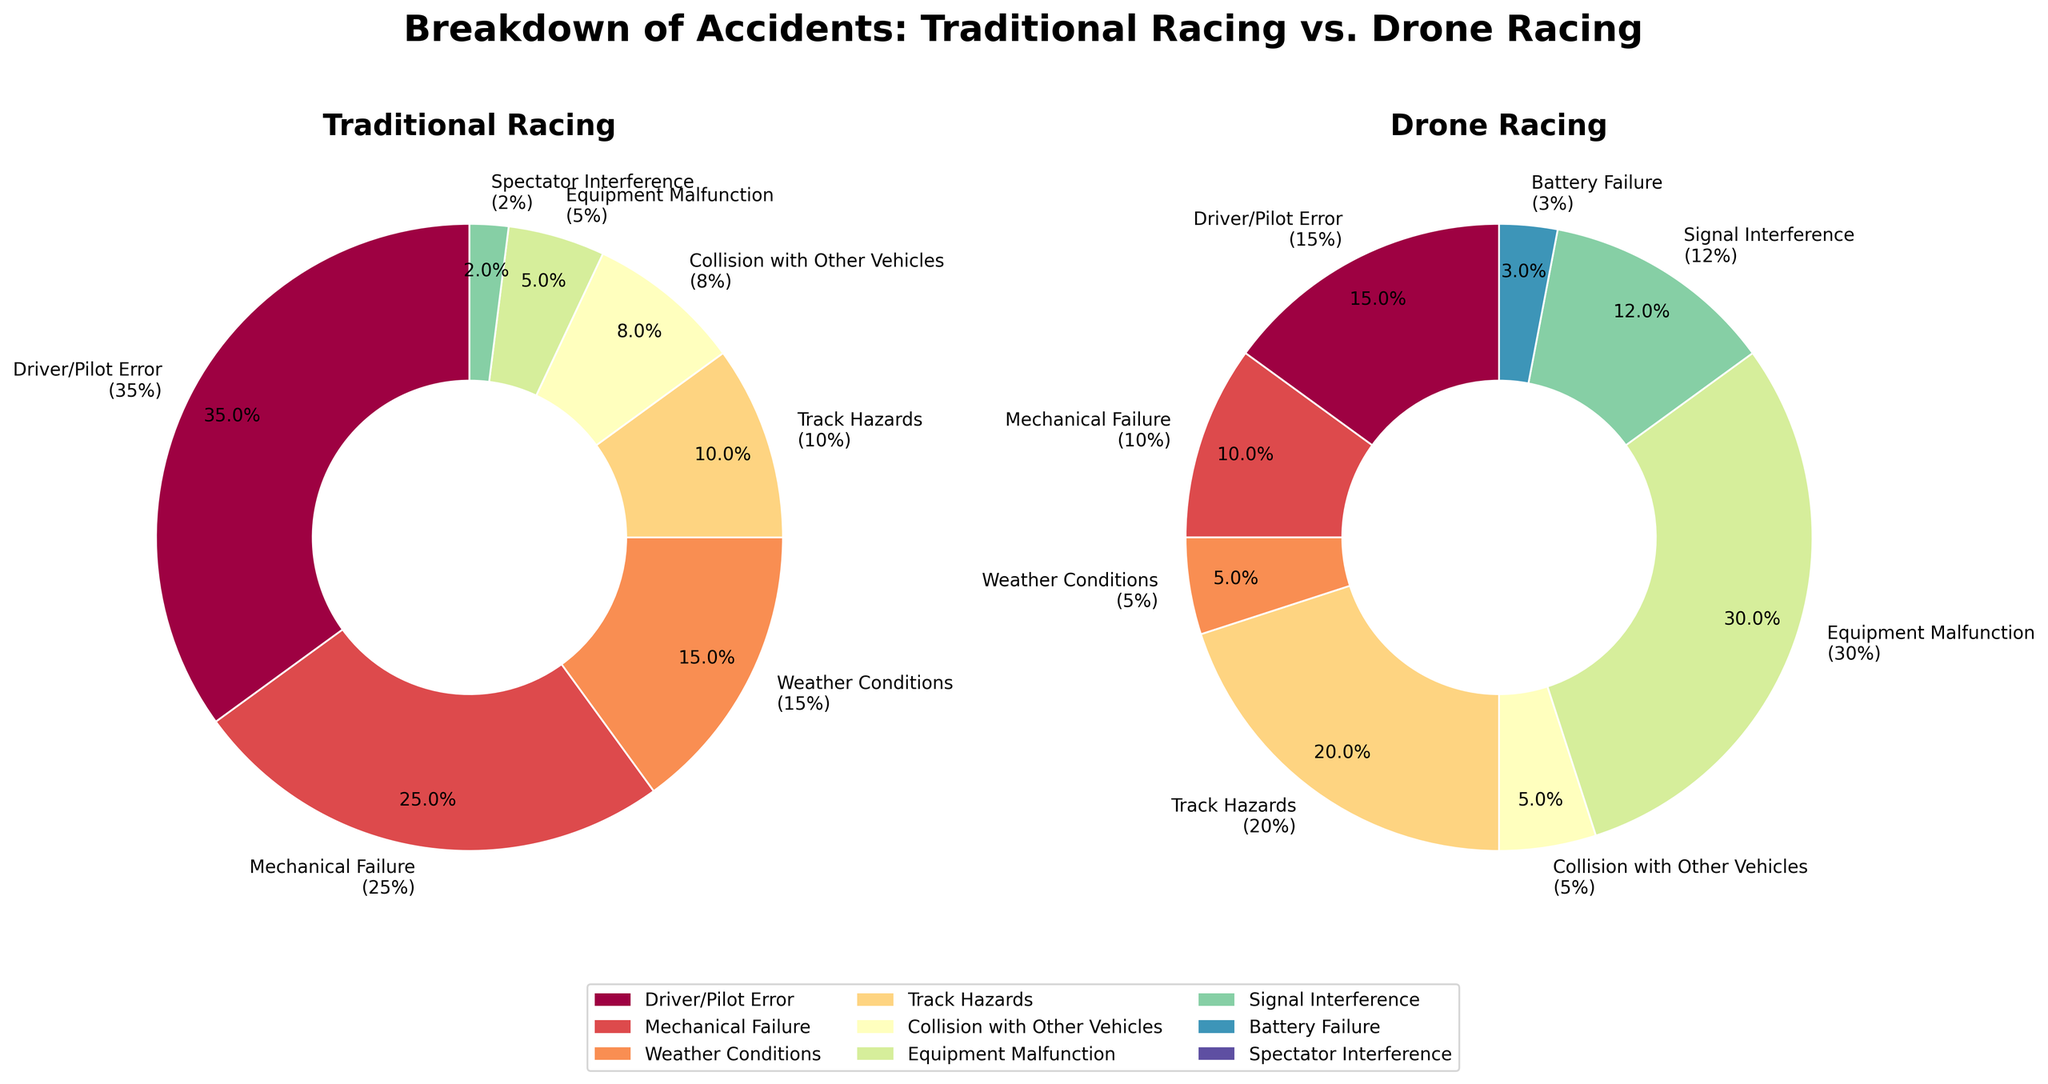Which cause has the highest percentage of accidents in traditional racing? Look at the section of the pie chart labeled "Driver/Pilot Error" in the traditional racing pie chart; it takes up the largest area.
Answer: Driver/Pilot Error What is the percentage difference of accidents caused by mechanical failure between traditional and drone racing? Identify the mechanical failure percentage in both charts and subtract the drone percentage from the traditional one: 25% - 10% = 15%.
Answer: 15% In both traditional and drone racing, which cause has a 0% accident rate? Find the causes not represented by any section of the pie chart. In both charts, "Signal Interference" and "Battery Failure" are only present in drone racing, and "Spectator Interference" is only in traditional racing. None of these causes have a 0% in both charts.
Answer: None What is the combined percentage for accidents caused by track hazards and equipment malfunction in drone racing? Sum the percentages for Track Hazards (20%) and Equipment Malfunction (30%) from the drone racing pie chart: 20% + 30% = 50%.
Answer: 50% Which category is more prominent in drone racing compared to traditional racing: Equipment Malfunction or Signal Interference? Compare the Equipment Malfunction (drone: 30%, traditional: 5%) with Signal Interference (drone: 12%, traditional: 0%). Both categories are more prominent, but Equipment Malfunction has a higher difference.
Answer: Equipment Malfunction How many categories have more than 20% of accidents in drone racing? Check the labels in the drone racing pie chart and count: Equipment Malfunction (30%) and Track Hazards (20%). There are 2 categories.
Answer: 2 Which type of racing has more categories without accidents? Compare the number of causes with a 0% occurrence in both pie charts: Traditional has Signal Interference and Battery Failure, while Drone has Spectator Interference. Traditional wins with 2 categories.
Answer: Traditional Racing What is the median percentage of causes in traditional racing? List the percentages (35%, 25%, 15%, 10%, 8%, 5%, 2%) and find the median value, which is the middle value: 10%.
Answer: 10% Which visual attribute helps you quickly identify the most common cause of accidents in both types of racing? The size of the pie sections (the area and width) compared with other causes in each respective chart helps identify the most common causes. The larger the section, the more prominent the cause.
Answer: Size of the pie sections 